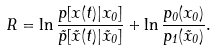<formula> <loc_0><loc_0><loc_500><loc_500>R = \ln \frac { p [ x ( t ) | x _ { 0 } ] } { \tilde { p } [ \tilde { x } ( t ) | \tilde { x } _ { 0 } ] } + \ln \frac { p _ { 0 } ( x _ { 0 } ) } { p _ { 1 } ( \tilde { x } _ { 0 } ) } .</formula> 